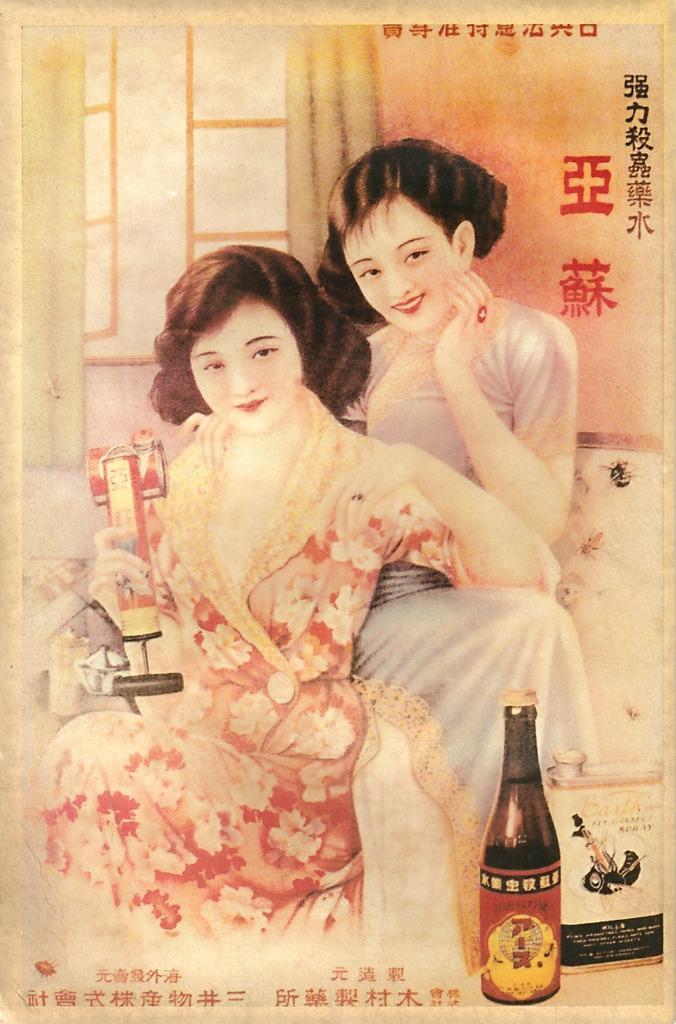Describe this image in one or two sentences. I see this is a poster in which there are 2 women and I see this woman is holding a thing and there is a bottle over here. In the background I see the window and the curtain. 